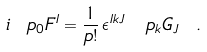Convert formula to latex. <formula><loc_0><loc_0><loc_500><loc_500>i \ p _ { 0 } F ^ { I } = \frac { 1 } { p ! } \, \epsilon ^ { I k J } \, \ p _ { k } G _ { J } \ .</formula> 